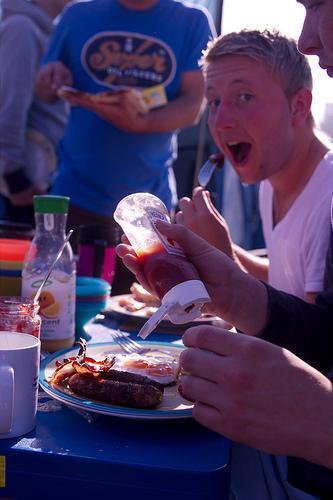How many people are there?
Give a very brief answer. 4. 